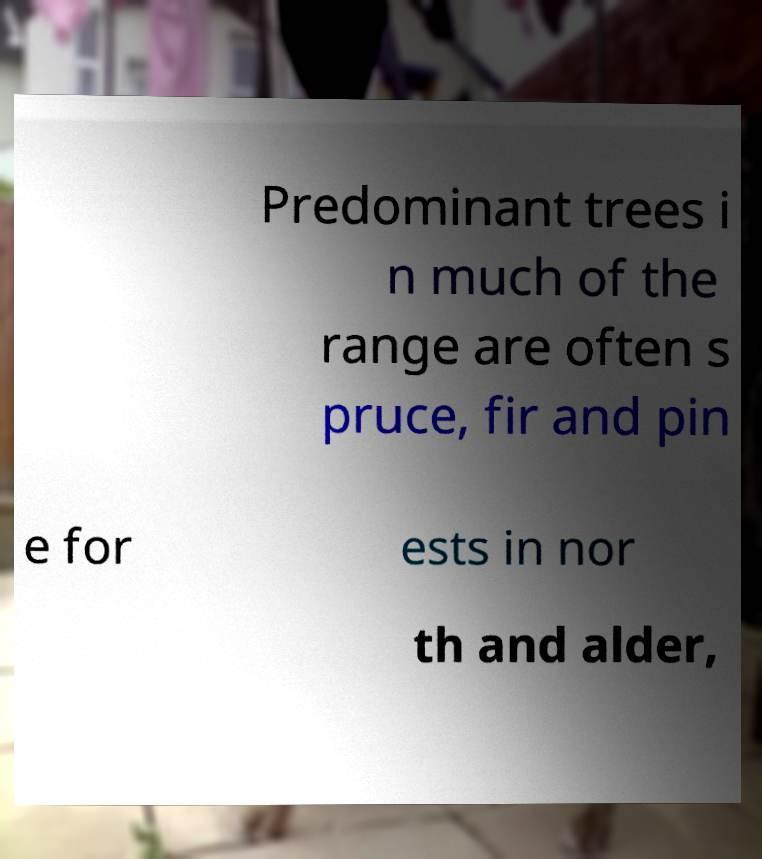Can you read and provide the text displayed in the image?This photo seems to have some interesting text. Can you extract and type it out for me? Predominant trees i n much of the range are often s pruce, fir and pin e for ests in nor th and alder, 